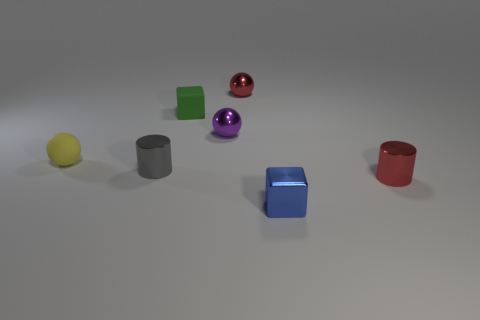Add 2 green objects. How many objects exist? 9 Subtract all cylinders. How many objects are left? 5 Add 5 gray cylinders. How many gray cylinders exist? 6 Subtract 0 purple cubes. How many objects are left? 7 Subtract all tiny cubes. Subtract all yellow matte spheres. How many objects are left? 4 Add 7 small cylinders. How many small cylinders are left? 9 